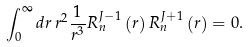<formula> <loc_0><loc_0><loc_500><loc_500>\int _ { 0 } ^ { \infty } d r \, r ^ { 2 } \frac { 1 } { r ^ { 3 } } R _ { n } ^ { J - 1 } \left ( r \right ) R _ { n } ^ { J + 1 } \left ( r \right ) = 0 .</formula> 